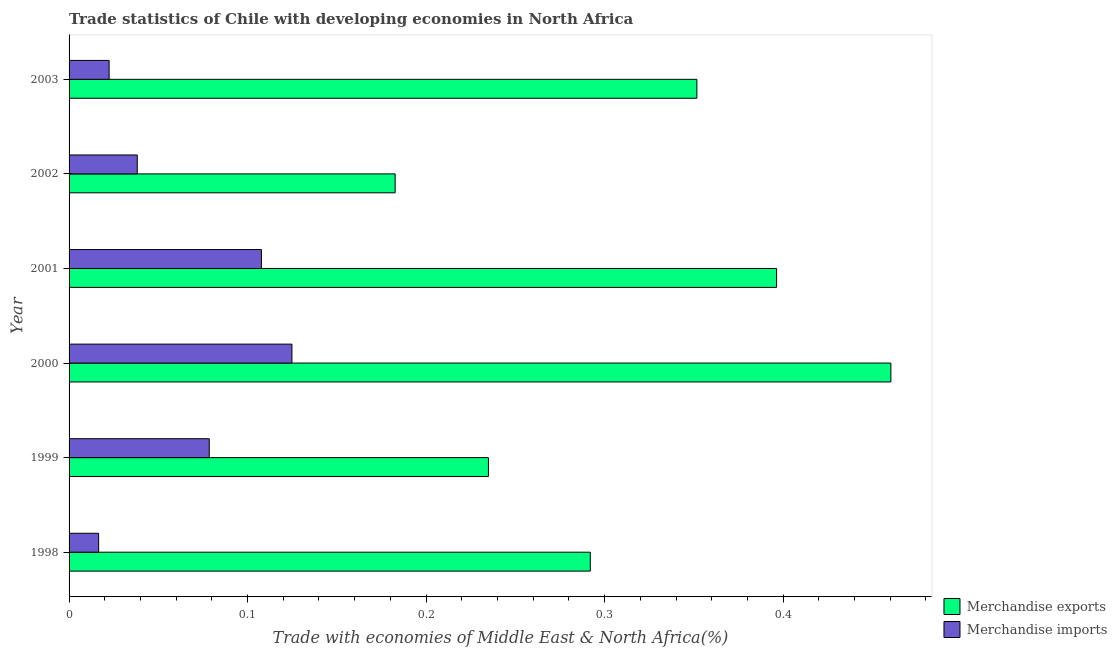How many different coloured bars are there?
Offer a very short reply. 2. How many bars are there on the 3rd tick from the top?
Provide a short and direct response. 2. In how many cases, is the number of bars for a given year not equal to the number of legend labels?
Make the answer very short. 0. What is the merchandise exports in 2001?
Your answer should be compact. 0.4. Across all years, what is the maximum merchandise imports?
Provide a short and direct response. 0.12. Across all years, what is the minimum merchandise exports?
Your answer should be compact. 0.18. In which year was the merchandise imports minimum?
Your response must be concise. 1998. What is the total merchandise exports in the graph?
Ensure brevity in your answer.  1.92. What is the difference between the merchandise exports in 2002 and the merchandise imports in 2000?
Provide a succinct answer. 0.06. What is the average merchandise imports per year?
Your response must be concise. 0.07. In the year 2002, what is the difference between the merchandise exports and merchandise imports?
Your response must be concise. 0.14. In how many years, is the merchandise exports greater than 0.08 %?
Give a very brief answer. 6. What is the ratio of the merchandise imports in 2000 to that in 2003?
Offer a very short reply. 5.56. Is the difference between the merchandise exports in 1998 and 2003 greater than the difference between the merchandise imports in 1998 and 2003?
Provide a short and direct response. No. What is the difference between the highest and the second highest merchandise imports?
Your response must be concise. 0.02. What is the difference between the highest and the lowest merchandise exports?
Your response must be concise. 0.28. In how many years, is the merchandise exports greater than the average merchandise exports taken over all years?
Ensure brevity in your answer.  3. Is the sum of the merchandise exports in 1998 and 2002 greater than the maximum merchandise imports across all years?
Ensure brevity in your answer.  Yes. How many bars are there?
Ensure brevity in your answer.  12. How many years are there in the graph?
Your answer should be very brief. 6. Does the graph contain any zero values?
Offer a terse response. No. What is the title of the graph?
Keep it short and to the point. Trade statistics of Chile with developing economies in North Africa. What is the label or title of the X-axis?
Keep it short and to the point. Trade with economies of Middle East & North Africa(%). What is the Trade with economies of Middle East & North Africa(%) of Merchandise exports in 1998?
Make the answer very short. 0.29. What is the Trade with economies of Middle East & North Africa(%) of Merchandise imports in 1998?
Your response must be concise. 0.02. What is the Trade with economies of Middle East & North Africa(%) of Merchandise exports in 1999?
Provide a short and direct response. 0.23. What is the Trade with economies of Middle East & North Africa(%) of Merchandise imports in 1999?
Ensure brevity in your answer.  0.08. What is the Trade with economies of Middle East & North Africa(%) in Merchandise exports in 2000?
Your answer should be very brief. 0.46. What is the Trade with economies of Middle East & North Africa(%) in Merchandise imports in 2000?
Give a very brief answer. 0.12. What is the Trade with economies of Middle East & North Africa(%) of Merchandise exports in 2001?
Make the answer very short. 0.4. What is the Trade with economies of Middle East & North Africa(%) in Merchandise imports in 2001?
Give a very brief answer. 0.11. What is the Trade with economies of Middle East & North Africa(%) in Merchandise exports in 2002?
Ensure brevity in your answer.  0.18. What is the Trade with economies of Middle East & North Africa(%) in Merchandise imports in 2002?
Offer a terse response. 0.04. What is the Trade with economies of Middle East & North Africa(%) in Merchandise exports in 2003?
Provide a succinct answer. 0.35. What is the Trade with economies of Middle East & North Africa(%) in Merchandise imports in 2003?
Keep it short and to the point. 0.02. Across all years, what is the maximum Trade with economies of Middle East & North Africa(%) of Merchandise exports?
Provide a short and direct response. 0.46. Across all years, what is the maximum Trade with economies of Middle East & North Africa(%) in Merchandise imports?
Keep it short and to the point. 0.12. Across all years, what is the minimum Trade with economies of Middle East & North Africa(%) in Merchandise exports?
Offer a very short reply. 0.18. Across all years, what is the minimum Trade with economies of Middle East & North Africa(%) of Merchandise imports?
Ensure brevity in your answer.  0.02. What is the total Trade with economies of Middle East & North Africa(%) of Merchandise exports in the graph?
Your answer should be very brief. 1.92. What is the total Trade with economies of Middle East & North Africa(%) in Merchandise imports in the graph?
Give a very brief answer. 0.39. What is the difference between the Trade with economies of Middle East & North Africa(%) in Merchandise exports in 1998 and that in 1999?
Provide a succinct answer. 0.06. What is the difference between the Trade with economies of Middle East & North Africa(%) in Merchandise imports in 1998 and that in 1999?
Keep it short and to the point. -0.06. What is the difference between the Trade with economies of Middle East & North Africa(%) in Merchandise exports in 1998 and that in 2000?
Provide a short and direct response. -0.17. What is the difference between the Trade with economies of Middle East & North Africa(%) in Merchandise imports in 1998 and that in 2000?
Ensure brevity in your answer.  -0.11. What is the difference between the Trade with economies of Middle East & North Africa(%) of Merchandise exports in 1998 and that in 2001?
Offer a terse response. -0.1. What is the difference between the Trade with economies of Middle East & North Africa(%) of Merchandise imports in 1998 and that in 2001?
Offer a very short reply. -0.09. What is the difference between the Trade with economies of Middle East & North Africa(%) of Merchandise exports in 1998 and that in 2002?
Your answer should be very brief. 0.11. What is the difference between the Trade with economies of Middle East & North Africa(%) of Merchandise imports in 1998 and that in 2002?
Give a very brief answer. -0.02. What is the difference between the Trade with economies of Middle East & North Africa(%) in Merchandise exports in 1998 and that in 2003?
Your answer should be very brief. -0.06. What is the difference between the Trade with economies of Middle East & North Africa(%) in Merchandise imports in 1998 and that in 2003?
Give a very brief answer. -0.01. What is the difference between the Trade with economies of Middle East & North Africa(%) of Merchandise exports in 1999 and that in 2000?
Offer a very short reply. -0.23. What is the difference between the Trade with economies of Middle East & North Africa(%) in Merchandise imports in 1999 and that in 2000?
Your response must be concise. -0.05. What is the difference between the Trade with economies of Middle East & North Africa(%) of Merchandise exports in 1999 and that in 2001?
Ensure brevity in your answer.  -0.16. What is the difference between the Trade with economies of Middle East & North Africa(%) of Merchandise imports in 1999 and that in 2001?
Offer a terse response. -0.03. What is the difference between the Trade with economies of Middle East & North Africa(%) of Merchandise exports in 1999 and that in 2002?
Offer a very short reply. 0.05. What is the difference between the Trade with economies of Middle East & North Africa(%) of Merchandise imports in 1999 and that in 2002?
Offer a very short reply. 0.04. What is the difference between the Trade with economies of Middle East & North Africa(%) of Merchandise exports in 1999 and that in 2003?
Provide a short and direct response. -0.12. What is the difference between the Trade with economies of Middle East & North Africa(%) of Merchandise imports in 1999 and that in 2003?
Offer a very short reply. 0.06. What is the difference between the Trade with economies of Middle East & North Africa(%) of Merchandise exports in 2000 and that in 2001?
Ensure brevity in your answer.  0.06. What is the difference between the Trade with economies of Middle East & North Africa(%) of Merchandise imports in 2000 and that in 2001?
Your response must be concise. 0.02. What is the difference between the Trade with economies of Middle East & North Africa(%) in Merchandise exports in 2000 and that in 2002?
Ensure brevity in your answer.  0.28. What is the difference between the Trade with economies of Middle East & North Africa(%) of Merchandise imports in 2000 and that in 2002?
Your answer should be very brief. 0.09. What is the difference between the Trade with economies of Middle East & North Africa(%) of Merchandise exports in 2000 and that in 2003?
Your answer should be compact. 0.11. What is the difference between the Trade with economies of Middle East & North Africa(%) of Merchandise imports in 2000 and that in 2003?
Your response must be concise. 0.1. What is the difference between the Trade with economies of Middle East & North Africa(%) in Merchandise exports in 2001 and that in 2002?
Your answer should be compact. 0.21. What is the difference between the Trade with economies of Middle East & North Africa(%) of Merchandise imports in 2001 and that in 2002?
Provide a short and direct response. 0.07. What is the difference between the Trade with economies of Middle East & North Africa(%) in Merchandise exports in 2001 and that in 2003?
Ensure brevity in your answer.  0.04. What is the difference between the Trade with economies of Middle East & North Africa(%) of Merchandise imports in 2001 and that in 2003?
Your answer should be compact. 0.09. What is the difference between the Trade with economies of Middle East & North Africa(%) of Merchandise exports in 2002 and that in 2003?
Offer a very short reply. -0.17. What is the difference between the Trade with economies of Middle East & North Africa(%) of Merchandise imports in 2002 and that in 2003?
Keep it short and to the point. 0.02. What is the difference between the Trade with economies of Middle East & North Africa(%) in Merchandise exports in 1998 and the Trade with economies of Middle East & North Africa(%) in Merchandise imports in 1999?
Provide a short and direct response. 0.21. What is the difference between the Trade with economies of Middle East & North Africa(%) of Merchandise exports in 1998 and the Trade with economies of Middle East & North Africa(%) of Merchandise imports in 2000?
Your answer should be very brief. 0.17. What is the difference between the Trade with economies of Middle East & North Africa(%) in Merchandise exports in 1998 and the Trade with economies of Middle East & North Africa(%) in Merchandise imports in 2001?
Give a very brief answer. 0.18. What is the difference between the Trade with economies of Middle East & North Africa(%) in Merchandise exports in 1998 and the Trade with economies of Middle East & North Africa(%) in Merchandise imports in 2002?
Provide a short and direct response. 0.25. What is the difference between the Trade with economies of Middle East & North Africa(%) of Merchandise exports in 1998 and the Trade with economies of Middle East & North Africa(%) of Merchandise imports in 2003?
Your response must be concise. 0.27. What is the difference between the Trade with economies of Middle East & North Africa(%) in Merchandise exports in 1999 and the Trade with economies of Middle East & North Africa(%) in Merchandise imports in 2000?
Provide a succinct answer. 0.11. What is the difference between the Trade with economies of Middle East & North Africa(%) in Merchandise exports in 1999 and the Trade with economies of Middle East & North Africa(%) in Merchandise imports in 2001?
Give a very brief answer. 0.13. What is the difference between the Trade with economies of Middle East & North Africa(%) of Merchandise exports in 1999 and the Trade with economies of Middle East & North Africa(%) of Merchandise imports in 2002?
Provide a succinct answer. 0.2. What is the difference between the Trade with economies of Middle East & North Africa(%) of Merchandise exports in 1999 and the Trade with economies of Middle East & North Africa(%) of Merchandise imports in 2003?
Make the answer very short. 0.21. What is the difference between the Trade with economies of Middle East & North Africa(%) of Merchandise exports in 2000 and the Trade with economies of Middle East & North Africa(%) of Merchandise imports in 2001?
Provide a short and direct response. 0.35. What is the difference between the Trade with economies of Middle East & North Africa(%) in Merchandise exports in 2000 and the Trade with economies of Middle East & North Africa(%) in Merchandise imports in 2002?
Your answer should be very brief. 0.42. What is the difference between the Trade with economies of Middle East & North Africa(%) in Merchandise exports in 2000 and the Trade with economies of Middle East & North Africa(%) in Merchandise imports in 2003?
Provide a succinct answer. 0.44. What is the difference between the Trade with economies of Middle East & North Africa(%) of Merchandise exports in 2001 and the Trade with economies of Middle East & North Africa(%) of Merchandise imports in 2002?
Make the answer very short. 0.36. What is the difference between the Trade with economies of Middle East & North Africa(%) of Merchandise exports in 2001 and the Trade with economies of Middle East & North Africa(%) of Merchandise imports in 2003?
Ensure brevity in your answer.  0.37. What is the difference between the Trade with economies of Middle East & North Africa(%) in Merchandise exports in 2002 and the Trade with economies of Middle East & North Africa(%) in Merchandise imports in 2003?
Offer a very short reply. 0.16. What is the average Trade with economies of Middle East & North Africa(%) of Merchandise exports per year?
Offer a terse response. 0.32. What is the average Trade with economies of Middle East & North Africa(%) in Merchandise imports per year?
Give a very brief answer. 0.06. In the year 1998, what is the difference between the Trade with economies of Middle East & North Africa(%) of Merchandise exports and Trade with economies of Middle East & North Africa(%) of Merchandise imports?
Provide a short and direct response. 0.28. In the year 1999, what is the difference between the Trade with economies of Middle East & North Africa(%) in Merchandise exports and Trade with economies of Middle East & North Africa(%) in Merchandise imports?
Your response must be concise. 0.16. In the year 2000, what is the difference between the Trade with economies of Middle East & North Africa(%) in Merchandise exports and Trade with economies of Middle East & North Africa(%) in Merchandise imports?
Offer a very short reply. 0.34. In the year 2001, what is the difference between the Trade with economies of Middle East & North Africa(%) in Merchandise exports and Trade with economies of Middle East & North Africa(%) in Merchandise imports?
Provide a succinct answer. 0.29. In the year 2002, what is the difference between the Trade with economies of Middle East & North Africa(%) of Merchandise exports and Trade with economies of Middle East & North Africa(%) of Merchandise imports?
Make the answer very short. 0.14. In the year 2003, what is the difference between the Trade with economies of Middle East & North Africa(%) in Merchandise exports and Trade with economies of Middle East & North Africa(%) in Merchandise imports?
Your answer should be compact. 0.33. What is the ratio of the Trade with economies of Middle East & North Africa(%) of Merchandise exports in 1998 to that in 1999?
Provide a short and direct response. 1.24. What is the ratio of the Trade with economies of Middle East & North Africa(%) in Merchandise imports in 1998 to that in 1999?
Your answer should be very brief. 0.21. What is the ratio of the Trade with economies of Middle East & North Africa(%) of Merchandise exports in 1998 to that in 2000?
Give a very brief answer. 0.63. What is the ratio of the Trade with economies of Middle East & North Africa(%) in Merchandise imports in 1998 to that in 2000?
Ensure brevity in your answer.  0.13. What is the ratio of the Trade with economies of Middle East & North Africa(%) in Merchandise exports in 1998 to that in 2001?
Your answer should be compact. 0.74. What is the ratio of the Trade with economies of Middle East & North Africa(%) in Merchandise imports in 1998 to that in 2001?
Ensure brevity in your answer.  0.15. What is the ratio of the Trade with economies of Middle East & North Africa(%) of Merchandise exports in 1998 to that in 2002?
Provide a short and direct response. 1.6. What is the ratio of the Trade with economies of Middle East & North Africa(%) in Merchandise imports in 1998 to that in 2002?
Provide a short and direct response. 0.43. What is the ratio of the Trade with economies of Middle East & North Africa(%) in Merchandise exports in 1998 to that in 2003?
Provide a short and direct response. 0.83. What is the ratio of the Trade with economies of Middle East & North Africa(%) in Merchandise imports in 1998 to that in 2003?
Provide a succinct answer. 0.74. What is the ratio of the Trade with economies of Middle East & North Africa(%) of Merchandise exports in 1999 to that in 2000?
Offer a very short reply. 0.51. What is the ratio of the Trade with economies of Middle East & North Africa(%) in Merchandise imports in 1999 to that in 2000?
Make the answer very short. 0.63. What is the ratio of the Trade with economies of Middle East & North Africa(%) of Merchandise exports in 1999 to that in 2001?
Provide a short and direct response. 0.59. What is the ratio of the Trade with economies of Middle East & North Africa(%) in Merchandise imports in 1999 to that in 2001?
Make the answer very short. 0.73. What is the ratio of the Trade with economies of Middle East & North Africa(%) of Merchandise exports in 1999 to that in 2002?
Ensure brevity in your answer.  1.29. What is the ratio of the Trade with economies of Middle East & North Africa(%) in Merchandise imports in 1999 to that in 2002?
Provide a short and direct response. 2.06. What is the ratio of the Trade with economies of Middle East & North Africa(%) of Merchandise exports in 1999 to that in 2003?
Your answer should be compact. 0.67. What is the ratio of the Trade with economies of Middle East & North Africa(%) of Merchandise imports in 1999 to that in 2003?
Keep it short and to the point. 3.5. What is the ratio of the Trade with economies of Middle East & North Africa(%) of Merchandise exports in 2000 to that in 2001?
Your answer should be very brief. 1.16. What is the ratio of the Trade with economies of Middle East & North Africa(%) of Merchandise imports in 2000 to that in 2001?
Provide a succinct answer. 1.16. What is the ratio of the Trade with economies of Middle East & North Africa(%) in Merchandise exports in 2000 to that in 2002?
Your response must be concise. 2.52. What is the ratio of the Trade with economies of Middle East & North Africa(%) in Merchandise imports in 2000 to that in 2002?
Your response must be concise. 3.27. What is the ratio of the Trade with economies of Middle East & North Africa(%) in Merchandise exports in 2000 to that in 2003?
Provide a short and direct response. 1.31. What is the ratio of the Trade with economies of Middle East & North Africa(%) in Merchandise imports in 2000 to that in 2003?
Provide a succinct answer. 5.56. What is the ratio of the Trade with economies of Middle East & North Africa(%) of Merchandise exports in 2001 to that in 2002?
Your answer should be very brief. 2.17. What is the ratio of the Trade with economies of Middle East & North Africa(%) of Merchandise imports in 2001 to that in 2002?
Your response must be concise. 2.82. What is the ratio of the Trade with economies of Middle East & North Africa(%) of Merchandise exports in 2001 to that in 2003?
Offer a terse response. 1.13. What is the ratio of the Trade with economies of Middle East & North Africa(%) in Merchandise imports in 2001 to that in 2003?
Ensure brevity in your answer.  4.8. What is the ratio of the Trade with economies of Middle East & North Africa(%) of Merchandise exports in 2002 to that in 2003?
Provide a succinct answer. 0.52. What is the ratio of the Trade with economies of Middle East & North Africa(%) in Merchandise imports in 2002 to that in 2003?
Provide a succinct answer. 1.7. What is the difference between the highest and the second highest Trade with economies of Middle East & North Africa(%) of Merchandise exports?
Keep it short and to the point. 0.06. What is the difference between the highest and the second highest Trade with economies of Middle East & North Africa(%) of Merchandise imports?
Keep it short and to the point. 0.02. What is the difference between the highest and the lowest Trade with economies of Middle East & North Africa(%) in Merchandise exports?
Offer a terse response. 0.28. What is the difference between the highest and the lowest Trade with economies of Middle East & North Africa(%) in Merchandise imports?
Keep it short and to the point. 0.11. 